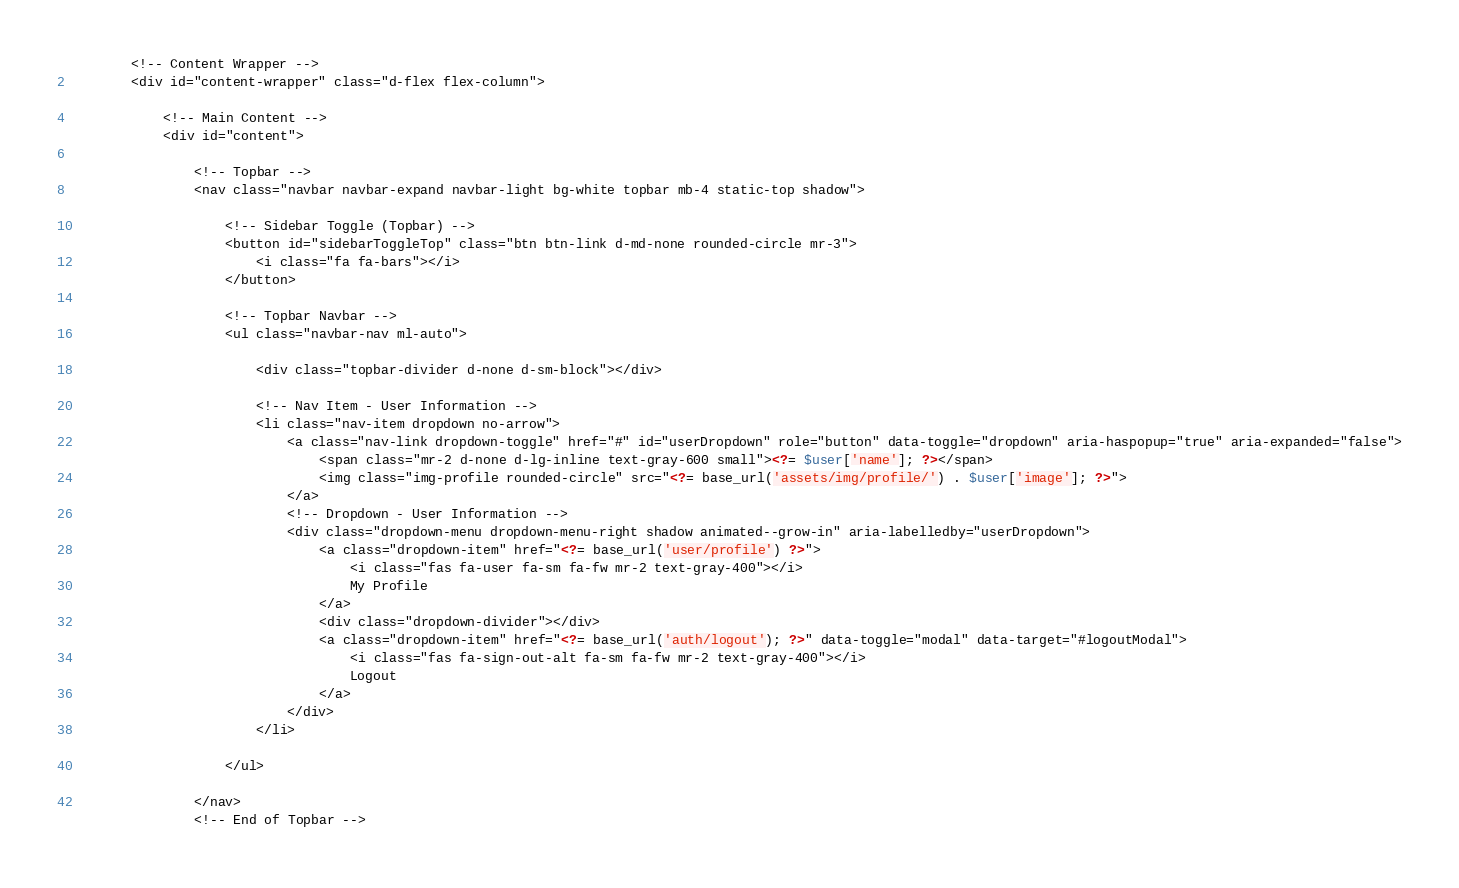<code> <loc_0><loc_0><loc_500><loc_500><_PHP_>        <!-- Content Wrapper -->
        <div id="content-wrapper" class="d-flex flex-column">

            <!-- Main Content -->
            <div id="content">

                <!-- Topbar -->
                <nav class="navbar navbar-expand navbar-light bg-white topbar mb-4 static-top shadow">

                    <!-- Sidebar Toggle (Topbar) -->
                    <button id="sidebarToggleTop" class="btn btn-link d-md-none rounded-circle mr-3">
                        <i class="fa fa-bars"></i>
                    </button>

                    <!-- Topbar Navbar -->
                    <ul class="navbar-nav ml-auto">

                        <div class="topbar-divider d-none d-sm-block"></div>

                        <!-- Nav Item - User Information -->
                        <li class="nav-item dropdown no-arrow">
                            <a class="nav-link dropdown-toggle" href="#" id="userDropdown" role="button" data-toggle="dropdown" aria-haspopup="true" aria-expanded="false">
                                <span class="mr-2 d-none d-lg-inline text-gray-600 small"><?= $user['name']; ?></span>
                                <img class="img-profile rounded-circle" src="<?= base_url('assets/img/profile/') . $user['image']; ?>">
                            </a>
                            <!-- Dropdown - User Information -->
                            <div class="dropdown-menu dropdown-menu-right shadow animated--grow-in" aria-labelledby="userDropdown">
                                <a class="dropdown-item" href="<?= base_url('user/profile') ?>">
                                    <i class="fas fa-user fa-sm fa-fw mr-2 text-gray-400"></i>
                                    My Profile
                                </a>
                                <div class="dropdown-divider"></div>
                                <a class="dropdown-item" href="<?= base_url('auth/logout'); ?>" data-toggle="modal" data-target="#logoutModal">
                                    <i class="fas fa-sign-out-alt fa-sm fa-fw mr-2 text-gray-400"></i>
                                    Logout
                                </a>
                            </div>
                        </li>

                    </ul>

                </nav>
                <!-- End of Topbar --> </code> 